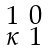<formula> <loc_0><loc_0><loc_500><loc_500>\begin{smallmatrix} 1 & 0 \\ \kappa & 1 \end{smallmatrix}</formula> 